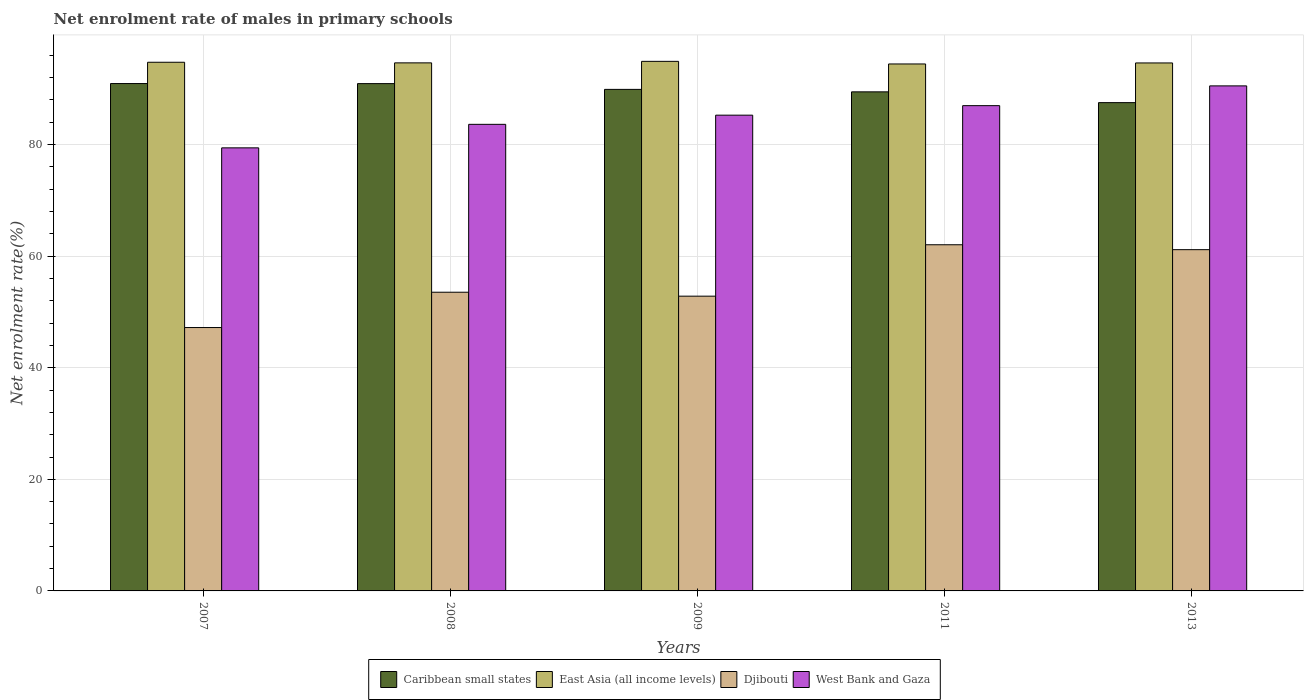How many different coloured bars are there?
Ensure brevity in your answer.  4. Are the number of bars per tick equal to the number of legend labels?
Your answer should be compact. Yes. Are the number of bars on each tick of the X-axis equal?
Your answer should be compact. Yes. How many bars are there on the 3rd tick from the right?
Provide a short and direct response. 4. In how many cases, is the number of bars for a given year not equal to the number of legend labels?
Keep it short and to the point. 0. What is the net enrolment rate of males in primary schools in Djibouti in 2007?
Your answer should be compact. 47.2. Across all years, what is the maximum net enrolment rate of males in primary schools in Djibouti?
Ensure brevity in your answer.  62.04. Across all years, what is the minimum net enrolment rate of males in primary schools in West Bank and Gaza?
Your answer should be very brief. 79.4. In which year was the net enrolment rate of males in primary schools in Djibouti minimum?
Make the answer very short. 2007. What is the total net enrolment rate of males in primary schools in Caribbean small states in the graph?
Make the answer very short. 448.67. What is the difference between the net enrolment rate of males in primary schools in Caribbean small states in 2007 and that in 2011?
Give a very brief answer. 1.49. What is the difference between the net enrolment rate of males in primary schools in Caribbean small states in 2007 and the net enrolment rate of males in primary schools in West Bank and Gaza in 2013?
Your answer should be very brief. 0.42. What is the average net enrolment rate of males in primary schools in East Asia (all income levels) per year?
Your response must be concise. 94.67. In the year 2007, what is the difference between the net enrolment rate of males in primary schools in Djibouti and net enrolment rate of males in primary schools in Caribbean small states?
Your response must be concise. -43.73. In how many years, is the net enrolment rate of males in primary schools in West Bank and Gaza greater than 20 %?
Ensure brevity in your answer.  5. What is the ratio of the net enrolment rate of males in primary schools in Caribbean small states in 2009 to that in 2013?
Provide a succinct answer. 1.03. Is the net enrolment rate of males in primary schools in Caribbean small states in 2008 less than that in 2009?
Provide a short and direct response. No. Is the difference between the net enrolment rate of males in primary schools in Djibouti in 2009 and 2011 greater than the difference between the net enrolment rate of males in primary schools in Caribbean small states in 2009 and 2011?
Provide a succinct answer. No. What is the difference between the highest and the second highest net enrolment rate of males in primary schools in East Asia (all income levels)?
Keep it short and to the point. 0.16. What is the difference between the highest and the lowest net enrolment rate of males in primary schools in East Asia (all income levels)?
Offer a terse response. 0.47. Is it the case that in every year, the sum of the net enrolment rate of males in primary schools in Djibouti and net enrolment rate of males in primary schools in East Asia (all income levels) is greater than the sum of net enrolment rate of males in primary schools in West Bank and Gaza and net enrolment rate of males in primary schools in Caribbean small states?
Offer a terse response. No. What does the 1st bar from the left in 2009 represents?
Your response must be concise. Caribbean small states. What does the 4th bar from the right in 2011 represents?
Provide a short and direct response. Caribbean small states. Is it the case that in every year, the sum of the net enrolment rate of males in primary schools in East Asia (all income levels) and net enrolment rate of males in primary schools in Caribbean small states is greater than the net enrolment rate of males in primary schools in Djibouti?
Your answer should be compact. Yes. Are all the bars in the graph horizontal?
Your response must be concise. No. What is the difference between two consecutive major ticks on the Y-axis?
Provide a succinct answer. 20. Does the graph contain any zero values?
Offer a very short reply. No. Does the graph contain grids?
Ensure brevity in your answer.  Yes. What is the title of the graph?
Your answer should be compact. Net enrolment rate of males in primary schools. What is the label or title of the Y-axis?
Your answer should be very brief. Net enrolment rate(%). What is the Net enrolment rate(%) in Caribbean small states in 2007?
Offer a terse response. 90.93. What is the Net enrolment rate(%) in East Asia (all income levels) in 2007?
Your answer should be very brief. 94.74. What is the Net enrolment rate(%) in Djibouti in 2007?
Make the answer very short. 47.2. What is the Net enrolment rate(%) of West Bank and Gaza in 2007?
Provide a short and direct response. 79.4. What is the Net enrolment rate(%) of Caribbean small states in 2008?
Offer a very short reply. 90.91. What is the Net enrolment rate(%) of East Asia (all income levels) in 2008?
Provide a succinct answer. 94.63. What is the Net enrolment rate(%) in Djibouti in 2008?
Your answer should be compact. 53.53. What is the Net enrolment rate(%) of West Bank and Gaza in 2008?
Your answer should be compact. 83.62. What is the Net enrolment rate(%) of Caribbean small states in 2009?
Your response must be concise. 89.88. What is the Net enrolment rate(%) of East Asia (all income levels) in 2009?
Offer a terse response. 94.9. What is the Net enrolment rate(%) of Djibouti in 2009?
Give a very brief answer. 52.82. What is the Net enrolment rate(%) in West Bank and Gaza in 2009?
Your response must be concise. 85.26. What is the Net enrolment rate(%) of Caribbean small states in 2011?
Provide a short and direct response. 89.44. What is the Net enrolment rate(%) in East Asia (all income levels) in 2011?
Your answer should be very brief. 94.44. What is the Net enrolment rate(%) of Djibouti in 2011?
Your response must be concise. 62.04. What is the Net enrolment rate(%) in West Bank and Gaza in 2011?
Ensure brevity in your answer.  86.97. What is the Net enrolment rate(%) in Caribbean small states in 2013?
Your answer should be compact. 87.51. What is the Net enrolment rate(%) in East Asia (all income levels) in 2013?
Ensure brevity in your answer.  94.62. What is the Net enrolment rate(%) of Djibouti in 2013?
Give a very brief answer. 61.16. What is the Net enrolment rate(%) of West Bank and Gaza in 2013?
Offer a very short reply. 90.51. Across all years, what is the maximum Net enrolment rate(%) in Caribbean small states?
Your response must be concise. 90.93. Across all years, what is the maximum Net enrolment rate(%) in East Asia (all income levels)?
Offer a terse response. 94.9. Across all years, what is the maximum Net enrolment rate(%) of Djibouti?
Your answer should be very brief. 62.04. Across all years, what is the maximum Net enrolment rate(%) in West Bank and Gaza?
Provide a succinct answer. 90.51. Across all years, what is the minimum Net enrolment rate(%) in Caribbean small states?
Offer a terse response. 87.51. Across all years, what is the minimum Net enrolment rate(%) in East Asia (all income levels)?
Give a very brief answer. 94.44. Across all years, what is the minimum Net enrolment rate(%) of Djibouti?
Your answer should be very brief. 47.2. Across all years, what is the minimum Net enrolment rate(%) of West Bank and Gaza?
Make the answer very short. 79.4. What is the total Net enrolment rate(%) of Caribbean small states in the graph?
Your answer should be very brief. 448.67. What is the total Net enrolment rate(%) in East Asia (all income levels) in the graph?
Make the answer very short. 473.33. What is the total Net enrolment rate(%) in Djibouti in the graph?
Give a very brief answer. 276.74. What is the total Net enrolment rate(%) in West Bank and Gaza in the graph?
Your answer should be very brief. 425.75. What is the difference between the Net enrolment rate(%) of Caribbean small states in 2007 and that in 2008?
Your answer should be very brief. 0.01. What is the difference between the Net enrolment rate(%) in East Asia (all income levels) in 2007 and that in 2008?
Keep it short and to the point. 0.11. What is the difference between the Net enrolment rate(%) of Djibouti in 2007 and that in 2008?
Provide a succinct answer. -6.33. What is the difference between the Net enrolment rate(%) of West Bank and Gaza in 2007 and that in 2008?
Offer a very short reply. -4.22. What is the difference between the Net enrolment rate(%) of Caribbean small states in 2007 and that in 2009?
Offer a very short reply. 1.05. What is the difference between the Net enrolment rate(%) of East Asia (all income levels) in 2007 and that in 2009?
Provide a short and direct response. -0.16. What is the difference between the Net enrolment rate(%) of Djibouti in 2007 and that in 2009?
Give a very brief answer. -5.62. What is the difference between the Net enrolment rate(%) in West Bank and Gaza in 2007 and that in 2009?
Give a very brief answer. -5.86. What is the difference between the Net enrolment rate(%) of Caribbean small states in 2007 and that in 2011?
Offer a terse response. 1.49. What is the difference between the Net enrolment rate(%) in East Asia (all income levels) in 2007 and that in 2011?
Provide a short and direct response. 0.31. What is the difference between the Net enrolment rate(%) in Djibouti in 2007 and that in 2011?
Provide a succinct answer. -14.84. What is the difference between the Net enrolment rate(%) in West Bank and Gaza in 2007 and that in 2011?
Keep it short and to the point. -7.56. What is the difference between the Net enrolment rate(%) of Caribbean small states in 2007 and that in 2013?
Provide a short and direct response. 3.42. What is the difference between the Net enrolment rate(%) in East Asia (all income levels) in 2007 and that in 2013?
Offer a very short reply. 0.12. What is the difference between the Net enrolment rate(%) of Djibouti in 2007 and that in 2013?
Provide a short and direct response. -13.96. What is the difference between the Net enrolment rate(%) in West Bank and Gaza in 2007 and that in 2013?
Your answer should be very brief. -11.11. What is the difference between the Net enrolment rate(%) in Caribbean small states in 2008 and that in 2009?
Give a very brief answer. 1.03. What is the difference between the Net enrolment rate(%) in East Asia (all income levels) in 2008 and that in 2009?
Make the answer very short. -0.27. What is the difference between the Net enrolment rate(%) of Djibouti in 2008 and that in 2009?
Your answer should be compact. 0.7. What is the difference between the Net enrolment rate(%) in West Bank and Gaza in 2008 and that in 2009?
Your answer should be compact. -1.64. What is the difference between the Net enrolment rate(%) in Caribbean small states in 2008 and that in 2011?
Give a very brief answer. 1.48. What is the difference between the Net enrolment rate(%) in East Asia (all income levels) in 2008 and that in 2011?
Ensure brevity in your answer.  0.2. What is the difference between the Net enrolment rate(%) of Djibouti in 2008 and that in 2011?
Your response must be concise. -8.51. What is the difference between the Net enrolment rate(%) of West Bank and Gaza in 2008 and that in 2011?
Give a very brief answer. -3.35. What is the difference between the Net enrolment rate(%) of Caribbean small states in 2008 and that in 2013?
Give a very brief answer. 3.41. What is the difference between the Net enrolment rate(%) of East Asia (all income levels) in 2008 and that in 2013?
Give a very brief answer. 0.01. What is the difference between the Net enrolment rate(%) of Djibouti in 2008 and that in 2013?
Ensure brevity in your answer.  -7.63. What is the difference between the Net enrolment rate(%) in West Bank and Gaza in 2008 and that in 2013?
Ensure brevity in your answer.  -6.89. What is the difference between the Net enrolment rate(%) in Caribbean small states in 2009 and that in 2011?
Your answer should be compact. 0.44. What is the difference between the Net enrolment rate(%) of East Asia (all income levels) in 2009 and that in 2011?
Offer a very short reply. 0.47. What is the difference between the Net enrolment rate(%) in Djibouti in 2009 and that in 2011?
Keep it short and to the point. -9.21. What is the difference between the Net enrolment rate(%) of West Bank and Gaza in 2009 and that in 2011?
Your answer should be compact. -1.71. What is the difference between the Net enrolment rate(%) in Caribbean small states in 2009 and that in 2013?
Give a very brief answer. 2.37. What is the difference between the Net enrolment rate(%) in East Asia (all income levels) in 2009 and that in 2013?
Offer a very short reply. 0.28. What is the difference between the Net enrolment rate(%) in Djibouti in 2009 and that in 2013?
Your answer should be very brief. -8.33. What is the difference between the Net enrolment rate(%) in West Bank and Gaza in 2009 and that in 2013?
Offer a terse response. -5.25. What is the difference between the Net enrolment rate(%) in Caribbean small states in 2011 and that in 2013?
Offer a very short reply. 1.93. What is the difference between the Net enrolment rate(%) in East Asia (all income levels) in 2011 and that in 2013?
Your answer should be compact. -0.18. What is the difference between the Net enrolment rate(%) of Djibouti in 2011 and that in 2013?
Provide a short and direct response. 0.88. What is the difference between the Net enrolment rate(%) of West Bank and Gaza in 2011 and that in 2013?
Ensure brevity in your answer.  -3.54. What is the difference between the Net enrolment rate(%) in Caribbean small states in 2007 and the Net enrolment rate(%) in East Asia (all income levels) in 2008?
Offer a terse response. -3.71. What is the difference between the Net enrolment rate(%) of Caribbean small states in 2007 and the Net enrolment rate(%) of Djibouti in 2008?
Your response must be concise. 37.4. What is the difference between the Net enrolment rate(%) of Caribbean small states in 2007 and the Net enrolment rate(%) of West Bank and Gaza in 2008?
Offer a terse response. 7.31. What is the difference between the Net enrolment rate(%) in East Asia (all income levels) in 2007 and the Net enrolment rate(%) in Djibouti in 2008?
Provide a short and direct response. 41.21. What is the difference between the Net enrolment rate(%) in East Asia (all income levels) in 2007 and the Net enrolment rate(%) in West Bank and Gaza in 2008?
Keep it short and to the point. 11.12. What is the difference between the Net enrolment rate(%) in Djibouti in 2007 and the Net enrolment rate(%) in West Bank and Gaza in 2008?
Your answer should be compact. -36.42. What is the difference between the Net enrolment rate(%) of Caribbean small states in 2007 and the Net enrolment rate(%) of East Asia (all income levels) in 2009?
Make the answer very short. -3.98. What is the difference between the Net enrolment rate(%) of Caribbean small states in 2007 and the Net enrolment rate(%) of Djibouti in 2009?
Keep it short and to the point. 38.1. What is the difference between the Net enrolment rate(%) of Caribbean small states in 2007 and the Net enrolment rate(%) of West Bank and Gaza in 2009?
Your answer should be very brief. 5.67. What is the difference between the Net enrolment rate(%) in East Asia (all income levels) in 2007 and the Net enrolment rate(%) in Djibouti in 2009?
Offer a terse response. 41.92. What is the difference between the Net enrolment rate(%) of East Asia (all income levels) in 2007 and the Net enrolment rate(%) of West Bank and Gaza in 2009?
Your answer should be very brief. 9.48. What is the difference between the Net enrolment rate(%) of Djibouti in 2007 and the Net enrolment rate(%) of West Bank and Gaza in 2009?
Offer a terse response. -38.06. What is the difference between the Net enrolment rate(%) of Caribbean small states in 2007 and the Net enrolment rate(%) of East Asia (all income levels) in 2011?
Provide a succinct answer. -3.51. What is the difference between the Net enrolment rate(%) in Caribbean small states in 2007 and the Net enrolment rate(%) in Djibouti in 2011?
Your answer should be very brief. 28.89. What is the difference between the Net enrolment rate(%) in Caribbean small states in 2007 and the Net enrolment rate(%) in West Bank and Gaza in 2011?
Provide a succinct answer. 3.96. What is the difference between the Net enrolment rate(%) in East Asia (all income levels) in 2007 and the Net enrolment rate(%) in Djibouti in 2011?
Make the answer very short. 32.71. What is the difference between the Net enrolment rate(%) in East Asia (all income levels) in 2007 and the Net enrolment rate(%) in West Bank and Gaza in 2011?
Your answer should be very brief. 7.78. What is the difference between the Net enrolment rate(%) of Djibouti in 2007 and the Net enrolment rate(%) of West Bank and Gaza in 2011?
Keep it short and to the point. -39.77. What is the difference between the Net enrolment rate(%) of Caribbean small states in 2007 and the Net enrolment rate(%) of East Asia (all income levels) in 2013?
Your answer should be very brief. -3.69. What is the difference between the Net enrolment rate(%) of Caribbean small states in 2007 and the Net enrolment rate(%) of Djibouti in 2013?
Your response must be concise. 29.77. What is the difference between the Net enrolment rate(%) in Caribbean small states in 2007 and the Net enrolment rate(%) in West Bank and Gaza in 2013?
Offer a very short reply. 0.42. What is the difference between the Net enrolment rate(%) of East Asia (all income levels) in 2007 and the Net enrolment rate(%) of Djibouti in 2013?
Offer a terse response. 33.58. What is the difference between the Net enrolment rate(%) in East Asia (all income levels) in 2007 and the Net enrolment rate(%) in West Bank and Gaza in 2013?
Offer a terse response. 4.23. What is the difference between the Net enrolment rate(%) of Djibouti in 2007 and the Net enrolment rate(%) of West Bank and Gaza in 2013?
Provide a succinct answer. -43.31. What is the difference between the Net enrolment rate(%) of Caribbean small states in 2008 and the Net enrolment rate(%) of East Asia (all income levels) in 2009?
Give a very brief answer. -3.99. What is the difference between the Net enrolment rate(%) in Caribbean small states in 2008 and the Net enrolment rate(%) in Djibouti in 2009?
Give a very brief answer. 38.09. What is the difference between the Net enrolment rate(%) of Caribbean small states in 2008 and the Net enrolment rate(%) of West Bank and Gaza in 2009?
Your answer should be very brief. 5.65. What is the difference between the Net enrolment rate(%) in East Asia (all income levels) in 2008 and the Net enrolment rate(%) in Djibouti in 2009?
Provide a short and direct response. 41.81. What is the difference between the Net enrolment rate(%) in East Asia (all income levels) in 2008 and the Net enrolment rate(%) in West Bank and Gaza in 2009?
Your answer should be very brief. 9.37. What is the difference between the Net enrolment rate(%) in Djibouti in 2008 and the Net enrolment rate(%) in West Bank and Gaza in 2009?
Make the answer very short. -31.73. What is the difference between the Net enrolment rate(%) of Caribbean small states in 2008 and the Net enrolment rate(%) of East Asia (all income levels) in 2011?
Make the answer very short. -3.52. What is the difference between the Net enrolment rate(%) in Caribbean small states in 2008 and the Net enrolment rate(%) in Djibouti in 2011?
Your answer should be compact. 28.88. What is the difference between the Net enrolment rate(%) of Caribbean small states in 2008 and the Net enrolment rate(%) of West Bank and Gaza in 2011?
Provide a succinct answer. 3.95. What is the difference between the Net enrolment rate(%) in East Asia (all income levels) in 2008 and the Net enrolment rate(%) in Djibouti in 2011?
Give a very brief answer. 32.6. What is the difference between the Net enrolment rate(%) in East Asia (all income levels) in 2008 and the Net enrolment rate(%) in West Bank and Gaza in 2011?
Ensure brevity in your answer.  7.67. What is the difference between the Net enrolment rate(%) of Djibouti in 2008 and the Net enrolment rate(%) of West Bank and Gaza in 2011?
Keep it short and to the point. -33.44. What is the difference between the Net enrolment rate(%) in Caribbean small states in 2008 and the Net enrolment rate(%) in East Asia (all income levels) in 2013?
Keep it short and to the point. -3.71. What is the difference between the Net enrolment rate(%) in Caribbean small states in 2008 and the Net enrolment rate(%) in Djibouti in 2013?
Your answer should be very brief. 29.76. What is the difference between the Net enrolment rate(%) of Caribbean small states in 2008 and the Net enrolment rate(%) of West Bank and Gaza in 2013?
Your answer should be compact. 0.41. What is the difference between the Net enrolment rate(%) in East Asia (all income levels) in 2008 and the Net enrolment rate(%) in Djibouti in 2013?
Offer a very short reply. 33.48. What is the difference between the Net enrolment rate(%) in East Asia (all income levels) in 2008 and the Net enrolment rate(%) in West Bank and Gaza in 2013?
Give a very brief answer. 4.13. What is the difference between the Net enrolment rate(%) of Djibouti in 2008 and the Net enrolment rate(%) of West Bank and Gaza in 2013?
Offer a terse response. -36.98. What is the difference between the Net enrolment rate(%) in Caribbean small states in 2009 and the Net enrolment rate(%) in East Asia (all income levels) in 2011?
Offer a very short reply. -4.56. What is the difference between the Net enrolment rate(%) in Caribbean small states in 2009 and the Net enrolment rate(%) in Djibouti in 2011?
Offer a terse response. 27.84. What is the difference between the Net enrolment rate(%) in Caribbean small states in 2009 and the Net enrolment rate(%) in West Bank and Gaza in 2011?
Your answer should be compact. 2.91. What is the difference between the Net enrolment rate(%) in East Asia (all income levels) in 2009 and the Net enrolment rate(%) in Djibouti in 2011?
Offer a terse response. 32.87. What is the difference between the Net enrolment rate(%) of East Asia (all income levels) in 2009 and the Net enrolment rate(%) of West Bank and Gaza in 2011?
Offer a very short reply. 7.94. What is the difference between the Net enrolment rate(%) of Djibouti in 2009 and the Net enrolment rate(%) of West Bank and Gaza in 2011?
Give a very brief answer. -34.14. What is the difference between the Net enrolment rate(%) of Caribbean small states in 2009 and the Net enrolment rate(%) of East Asia (all income levels) in 2013?
Your response must be concise. -4.74. What is the difference between the Net enrolment rate(%) in Caribbean small states in 2009 and the Net enrolment rate(%) in Djibouti in 2013?
Give a very brief answer. 28.72. What is the difference between the Net enrolment rate(%) in Caribbean small states in 2009 and the Net enrolment rate(%) in West Bank and Gaza in 2013?
Give a very brief answer. -0.63. What is the difference between the Net enrolment rate(%) in East Asia (all income levels) in 2009 and the Net enrolment rate(%) in Djibouti in 2013?
Your response must be concise. 33.75. What is the difference between the Net enrolment rate(%) of East Asia (all income levels) in 2009 and the Net enrolment rate(%) of West Bank and Gaza in 2013?
Your response must be concise. 4.4. What is the difference between the Net enrolment rate(%) of Djibouti in 2009 and the Net enrolment rate(%) of West Bank and Gaza in 2013?
Make the answer very short. -37.68. What is the difference between the Net enrolment rate(%) of Caribbean small states in 2011 and the Net enrolment rate(%) of East Asia (all income levels) in 2013?
Provide a short and direct response. -5.18. What is the difference between the Net enrolment rate(%) of Caribbean small states in 2011 and the Net enrolment rate(%) of Djibouti in 2013?
Your response must be concise. 28.28. What is the difference between the Net enrolment rate(%) in Caribbean small states in 2011 and the Net enrolment rate(%) in West Bank and Gaza in 2013?
Ensure brevity in your answer.  -1.07. What is the difference between the Net enrolment rate(%) of East Asia (all income levels) in 2011 and the Net enrolment rate(%) of Djibouti in 2013?
Give a very brief answer. 33.28. What is the difference between the Net enrolment rate(%) in East Asia (all income levels) in 2011 and the Net enrolment rate(%) in West Bank and Gaza in 2013?
Give a very brief answer. 3.93. What is the difference between the Net enrolment rate(%) of Djibouti in 2011 and the Net enrolment rate(%) of West Bank and Gaza in 2013?
Make the answer very short. -28.47. What is the average Net enrolment rate(%) of Caribbean small states per year?
Offer a terse response. 89.73. What is the average Net enrolment rate(%) of East Asia (all income levels) per year?
Your answer should be compact. 94.67. What is the average Net enrolment rate(%) of Djibouti per year?
Make the answer very short. 55.35. What is the average Net enrolment rate(%) of West Bank and Gaza per year?
Your response must be concise. 85.15. In the year 2007, what is the difference between the Net enrolment rate(%) of Caribbean small states and Net enrolment rate(%) of East Asia (all income levels)?
Ensure brevity in your answer.  -3.82. In the year 2007, what is the difference between the Net enrolment rate(%) of Caribbean small states and Net enrolment rate(%) of Djibouti?
Provide a short and direct response. 43.73. In the year 2007, what is the difference between the Net enrolment rate(%) of Caribbean small states and Net enrolment rate(%) of West Bank and Gaza?
Ensure brevity in your answer.  11.52. In the year 2007, what is the difference between the Net enrolment rate(%) of East Asia (all income levels) and Net enrolment rate(%) of Djibouti?
Your answer should be very brief. 47.54. In the year 2007, what is the difference between the Net enrolment rate(%) of East Asia (all income levels) and Net enrolment rate(%) of West Bank and Gaza?
Provide a short and direct response. 15.34. In the year 2007, what is the difference between the Net enrolment rate(%) in Djibouti and Net enrolment rate(%) in West Bank and Gaza?
Ensure brevity in your answer.  -32.2. In the year 2008, what is the difference between the Net enrolment rate(%) of Caribbean small states and Net enrolment rate(%) of East Asia (all income levels)?
Offer a very short reply. -3.72. In the year 2008, what is the difference between the Net enrolment rate(%) of Caribbean small states and Net enrolment rate(%) of Djibouti?
Offer a very short reply. 37.39. In the year 2008, what is the difference between the Net enrolment rate(%) in Caribbean small states and Net enrolment rate(%) in West Bank and Gaza?
Provide a short and direct response. 7.3. In the year 2008, what is the difference between the Net enrolment rate(%) of East Asia (all income levels) and Net enrolment rate(%) of Djibouti?
Provide a short and direct response. 41.1. In the year 2008, what is the difference between the Net enrolment rate(%) of East Asia (all income levels) and Net enrolment rate(%) of West Bank and Gaza?
Offer a terse response. 11.01. In the year 2008, what is the difference between the Net enrolment rate(%) of Djibouti and Net enrolment rate(%) of West Bank and Gaza?
Offer a very short reply. -30.09. In the year 2009, what is the difference between the Net enrolment rate(%) of Caribbean small states and Net enrolment rate(%) of East Asia (all income levels)?
Your response must be concise. -5.02. In the year 2009, what is the difference between the Net enrolment rate(%) of Caribbean small states and Net enrolment rate(%) of Djibouti?
Your response must be concise. 37.06. In the year 2009, what is the difference between the Net enrolment rate(%) of Caribbean small states and Net enrolment rate(%) of West Bank and Gaza?
Keep it short and to the point. 4.62. In the year 2009, what is the difference between the Net enrolment rate(%) in East Asia (all income levels) and Net enrolment rate(%) in Djibouti?
Your answer should be compact. 42.08. In the year 2009, what is the difference between the Net enrolment rate(%) of East Asia (all income levels) and Net enrolment rate(%) of West Bank and Gaza?
Your response must be concise. 9.64. In the year 2009, what is the difference between the Net enrolment rate(%) of Djibouti and Net enrolment rate(%) of West Bank and Gaza?
Ensure brevity in your answer.  -32.44. In the year 2011, what is the difference between the Net enrolment rate(%) in Caribbean small states and Net enrolment rate(%) in East Asia (all income levels)?
Your response must be concise. -5. In the year 2011, what is the difference between the Net enrolment rate(%) of Caribbean small states and Net enrolment rate(%) of Djibouti?
Your answer should be very brief. 27.4. In the year 2011, what is the difference between the Net enrolment rate(%) in Caribbean small states and Net enrolment rate(%) in West Bank and Gaza?
Your answer should be compact. 2.47. In the year 2011, what is the difference between the Net enrolment rate(%) in East Asia (all income levels) and Net enrolment rate(%) in Djibouti?
Your response must be concise. 32.4. In the year 2011, what is the difference between the Net enrolment rate(%) in East Asia (all income levels) and Net enrolment rate(%) in West Bank and Gaza?
Your response must be concise. 7.47. In the year 2011, what is the difference between the Net enrolment rate(%) of Djibouti and Net enrolment rate(%) of West Bank and Gaza?
Provide a short and direct response. -24.93. In the year 2013, what is the difference between the Net enrolment rate(%) of Caribbean small states and Net enrolment rate(%) of East Asia (all income levels)?
Your answer should be compact. -7.11. In the year 2013, what is the difference between the Net enrolment rate(%) in Caribbean small states and Net enrolment rate(%) in Djibouti?
Your answer should be very brief. 26.35. In the year 2013, what is the difference between the Net enrolment rate(%) in Caribbean small states and Net enrolment rate(%) in West Bank and Gaza?
Give a very brief answer. -3. In the year 2013, what is the difference between the Net enrolment rate(%) of East Asia (all income levels) and Net enrolment rate(%) of Djibouti?
Make the answer very short. 33.46. In the year 2013, what is the difference between the Net enrolment rate(%) in East Asia (all income levels) and Net enrolment rate(%) in West Bank and Gaza?
Make the answer very short. 4.11. In the year 2013, what is the difference between the Net enrolment rate(%) in Djibouti and Net enrolment rate(%) in West Bank and Gaza?
Provide a short and direct response. -29.35. What is the ratio of the Net enrolment rate(%) in Caribbean small states in 2007 to that in 2008?
Offer a very short reply. 1. What is the ratio of the Net enrolment rate(%) in East Asia (all income levels) in 2007 to that in 2008?
Your response must be concise. 1. What is the ratio of the Net enrolment rate(%) of Djibouti in 2007 to that in 2008?
Ensure brevity in your answer.  0.88. What is the ratio of the Net enrolment rate(%) of West Bank and Gaza in 2007 to that in 2008?
Provide a short and direct response. 0.95. What is the ratio of the Net enrolment rate(%) in Caribbean small states in 2007 to that in 2009?
Make the answer very short. 1.01. What is the ratio of the Net enrolment rate(%) of East Asia (all income levels) in 2007 to that in 2009?
Your response must be concise. 1. What is the ratio of the Net enrolment rate(%) in Djibouti in 2007 to that in 2009?
Provide a short and direct response. 0.89. What is the ratio of the Net enrolment rate(%) in West Bank and Gaza in 2007 to that in 2009?
Your answer should be compact. 0.93. What is the ratio of the Net enrolment rate(%) in Caribbean small states in 2007 to that in 2011?
Offer a very short reply. 1.02. What is the ratio of the Net enrolment rate(%) of Djibouti in 2007 to that in 2011?
Ensure brevity in your answer.  0.76. What is the ratio of the Net enrolment rate(%) of West Bank and Gaza in 2007 to that in 2011?
Make the answer very short. 0.91. What is the ratio of the Net enrolment rate(%) of Caribbean small states in 2007 to that in 2013?
Your response must be concise. 1.04. What is the ratio of the Net enrolment rate(%) of Djibouti in 2007 to that in 2013?
Give a very brief answer. 0.77. What is the ratio of the Net enrolment rate(%) in West Bank and Gaza in 2007 to that in 2013?
Keep it short and to the point. 0.88. What is the ratio of the Net enrolment rate(%) of Caribbean small states in 2008 to that in 2009?
Provide a succinct answer. 1.01. What is the ratio of the Net enrolment rate(%) of Djibouti in 2008 to that in 2009?
Your answer should be compact. 1.01. What is the ratio of the Net enrolment rate(%) in West Bank and Gaza in 2008 to that in 2009?
Your answer should be very brief. 0.98. What is the ratio of the Net enrolment rate(%) in Caribbean small states in 2008 to that in 2011?
Your response must be concise. 1.02. What is the ratio of the Net enrolment rate(%) in East Asia (all income levels) in 2008 to that in 2011?
Your response must be concise. 1. What is the ratio of the Net enrolment rate(%) in Djibouti in 2008 to that in 2011?
Offer a terse response. 0.86. What is the ratio of the Net enrolment rate(%) in West Bank and Gaza in 2008 to that in 2011?
Offer a very short reply. 0.96. What is the ratio of the Net enrolment rate(%) in Caribbean small states in 2008 to that in 2013?
Keep it short and to the point. 1.04. What is the ratio of the Net enrolment rate(%) in Djibouti in 2008 to that in 2013?
Your response must be concise. 0.88. What is the ratio of the Net enrolment rate(%) in West Bank and Gaza in 2008 to that in 2013?
Offer a very short reply. 0.92. What is the ratio of the Net enrolment rate(%) in Caribbean small states in 2009 to that in 2011?
Offer a very short reply. 1. What is the ratio of the Net enrolment rate(%) in East Asia (all income levels) in 2009 to that in 2011?
Offer a very short reply. 1. What is the ratio of the Net enrolment rate(%) of Djibouti in 2009 to that in 2011?
Your answer should be very brief. 0.85. What is the ratio of the Net enrolment rate(%) of West Bank and Gaza in 2009 to that in 2011?
Your response must be concise. 0.98. What is the ratio of the Net enrolment rate(%) of Caribbean small states in 2009 to that in 2013?
Provide a succinct answer. 1.03. What is the ratio of the Net enrolment rate(%) of Djibouti in 2009 to that in 2013?
Offer a terse response. 0.86. What is the ratio of the Net enrolment rate(%) in West Bank and Gaza in 2009 to that in 2013?
Your response must be concise. 0.94. What is the ratio of the Net enrolment rate(%) in Caribbean small states in 2011 to that in 2013?
Your answer should be very brief. 1.02. What is the ratio of the Net enrolment rate(%) of East Asia (all income levels) in 2011 to that in 2013?
Make the answer very short. 1. What is the ratio of the Net enrolment rate(%) in Djibouti in 2011 to that in 2013?
Make the answer very short. 1.01. What is the ratio of the Net enrolment rate(%) of West Bank and Gaza in 2011 to that in 2013?
Make the answer very short. 0.96. What is the difference between the highest and the second highest Net enrolment rate(%) of Caribbean small states?
Offer a terse response. 0.01. What is the difference between the highest and the second highest Net enrolment rate(%) in East Asia (all income levels)?
Ensure brevity in your answer.  0.16. What is the difference between the highest and the second highest Net enrolment rate(%) of Djibouti?
Offer a terse response. 0.88. What is the difference between the highest and the second highest Net enrolment rate(%) of West Bank and Gaza?
Keep it short and to the point. 3.54. What is the difference between the highest and the lowest Net enrolment rate(%) of Caribbean small states?
Offer a very short reply. 3.42. What is the difference between the highest and the lowest Net enrolment rate(%) in East Asia (all income levels)?
Your response must be concise. 0.47. What is the difference between the highest and the lowest Net enrolment rate(%) of Djibouti?
Keep it short and to the point. 14.84. What is the difference between the highest and the lowest Net enrolment rate(%) of West Bank and Gaza?
Offer a terse response. 11.11. 